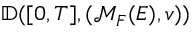Convert formula to latex. <formula><loc_0><loc_0><loc_500><loc_500>\mathbb { D } ( [ 0 , T ] , ( \mathcal { M } _ { F } ( E ) , v ) )</formula> 